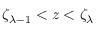<formula> <loc_0><loc_0><loc_500><loc_500>\zeta _ { \lambda - 1 } < z < \zeta _ { \lambda }</formula> 